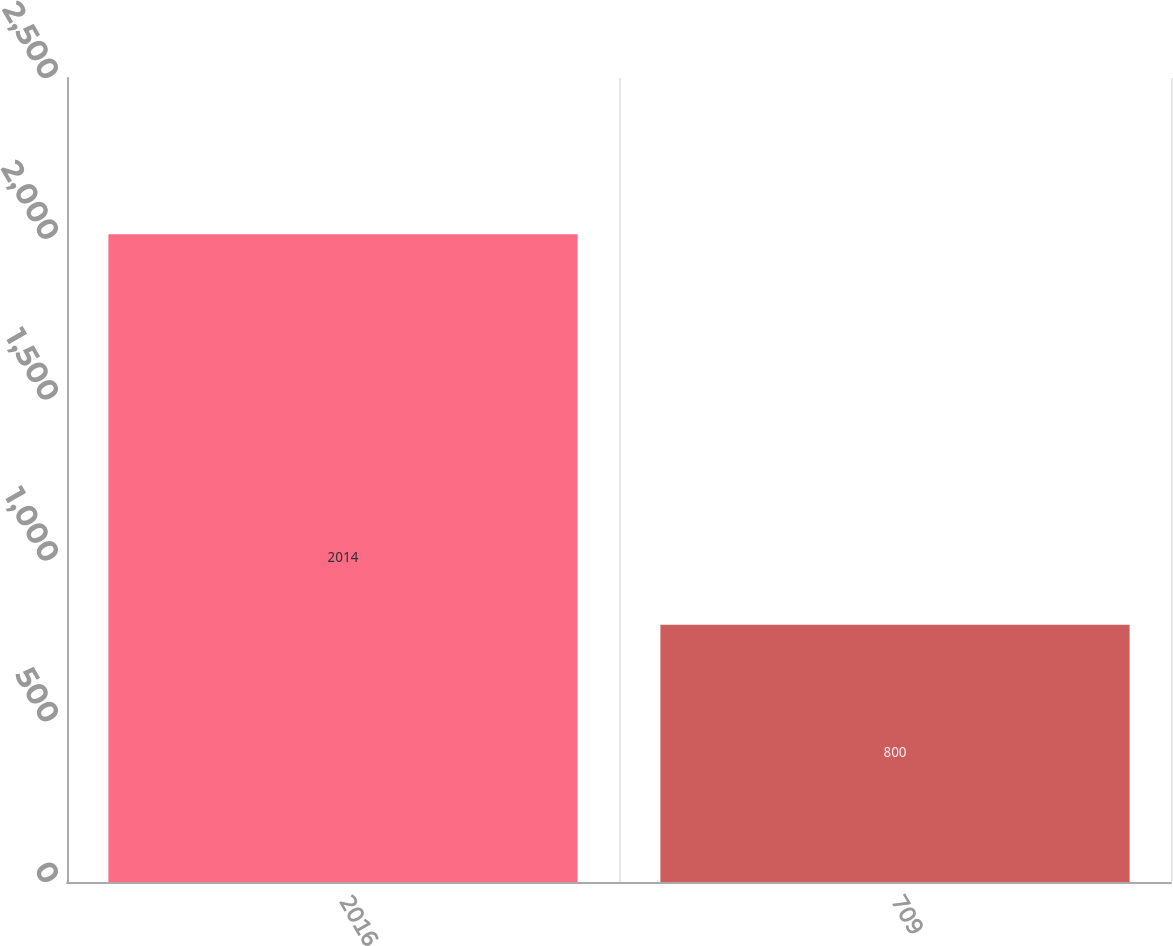<chart> <loc_0><loc_0><loc_500><loc_500><bar_chart><fcel>2016<fcel>709<nl><fcel>2014<fcel>800<nl></chart> 